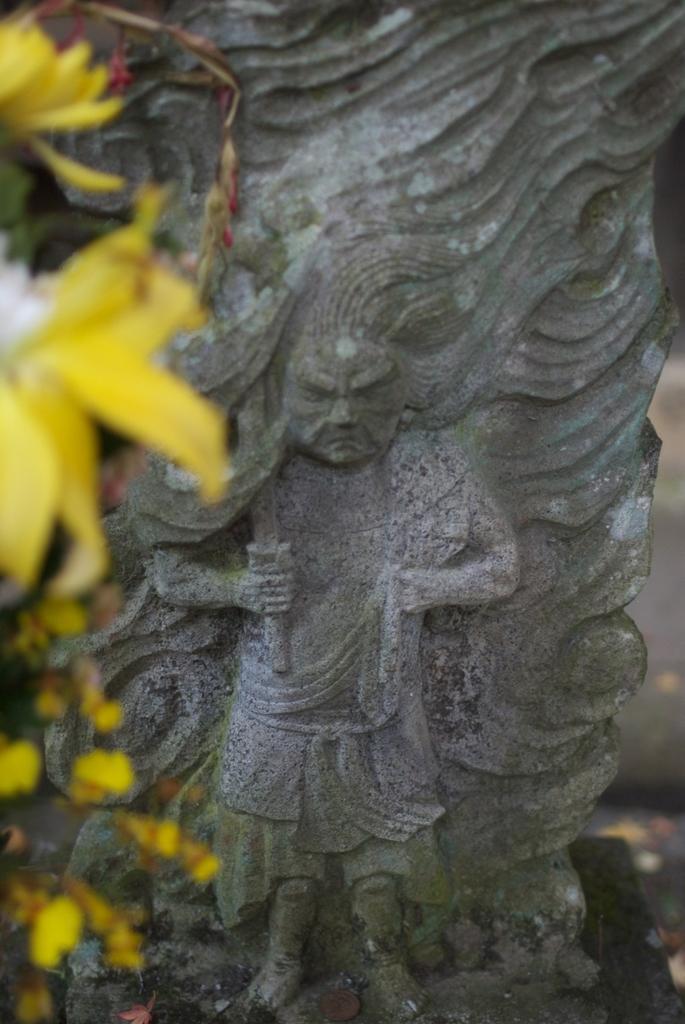Describe this image in one or two sentences. As we can see in the image there is sculpture and yellow color flowers on the left side. 